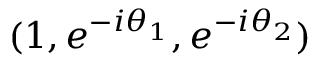<formula> <loc_0><loc_0><loc_500><loc_500>( 1 , e ^ { - i \theta _ { 1 } } , e ^ { - i \theta _ { 2 } } )</formula> 